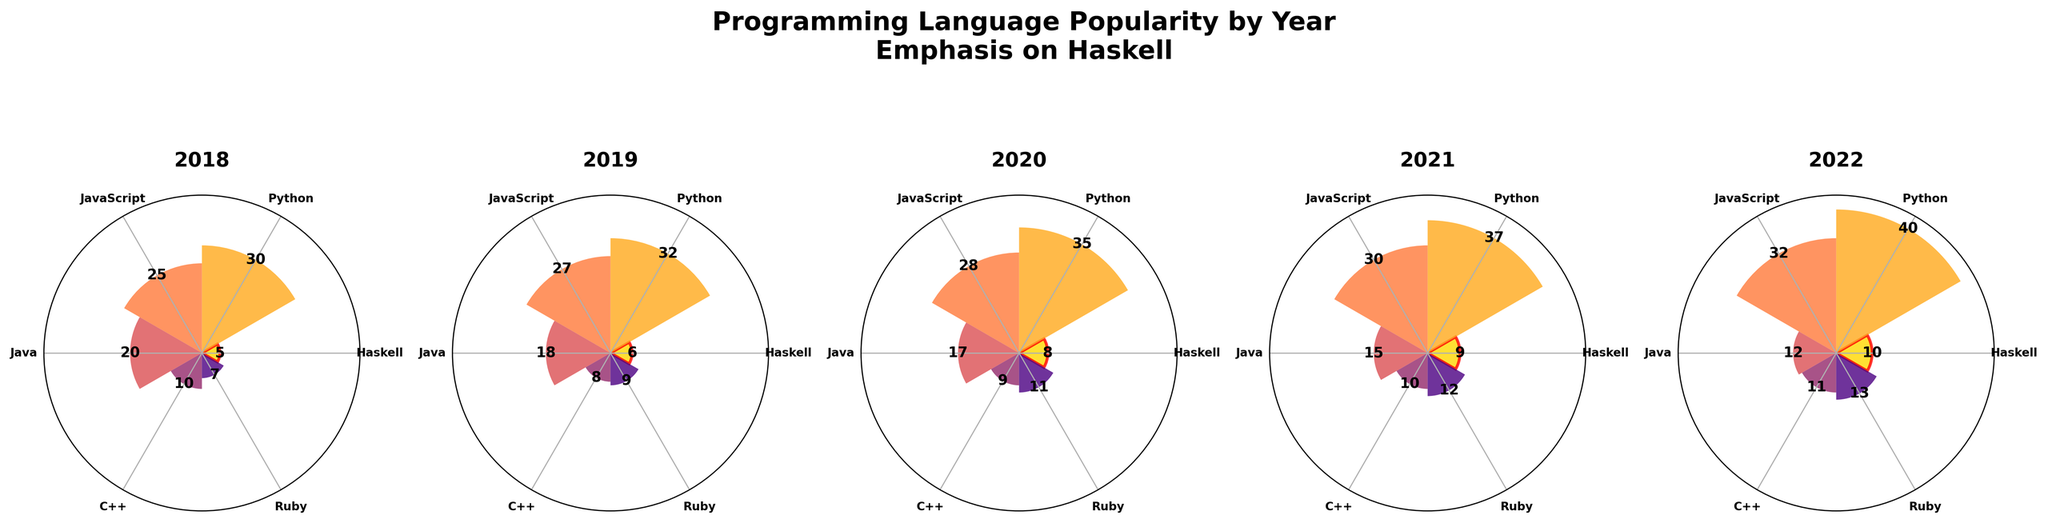What is the title of the figure? The title of the figure is displayed at the top of the image and reads "Programming Language Popularity by Year\nEmphasis on Haskell"
Answer: Programming Language Popularity by Year Emphasis on Haskell How many subplots are there in the figure? The figure consists of panels for each year from 2018 to 2022. By counting the labels, we see there are markers for five years.
Answer: 5 Which year had the highest popularity score for Haskell? By examining the values displayed on the Haskell bars (highlighted with a red border) across all subplots from 2018 to 2022, the highest value is 10 in 2022.
Answer: 2022 How does the popularity of Python change over the years? By looking at the values next to the Python bars across each subplot from 2018 to 2022, we can see the popularity scores (30, 32, 35, 37, 40) which show a consistent increase.
Answer: It increases every year What was the popularity score of Java in 2020? The value labeled next to the Java bar in the 2020 subplot is 17.
Answer: 17 Compare the popularity of JavaScript in 2018 and 2022. Which year was it more popular? By comparing the values next to the JavaScript bars in the 2018 (25) and 2022 (32) subplots, we see that JavaScript was more popular in 2022.
Answer: 2022 What is the combined popularity of C++ across 2019 and 2020? To find this, sum the values labeled next to the C++ bars in 2019 (8) and 2020 (9), which is 8 + 9 = 17.
Answer: 17 Which language had the lowest popularity in 2019? By comparing the values in the 2019 subplot, we see the lowest value belongs to C++ with a value of 8.
Answer: C++ How does the popularity trend of Ruby compare to that of Haskell across the years? To determine this, compare the values for Ruby (7, 9, 11, 12, 13) to those for Haskell (5, 6, 8, 9, 10). Both show an increasing trend, but Ruby's increase is steeper.
Answer: Both increase, but Ruby increases more From 2018 to 2022, which programming language shows the steadiest growth and what can you infer about its trend? By examining each programming language's values year-over-year, Python (30, 32, 35, 37, 40) shows a steady increase each year, indicating a continuous consistent growth in popularity.
Answer: Python 